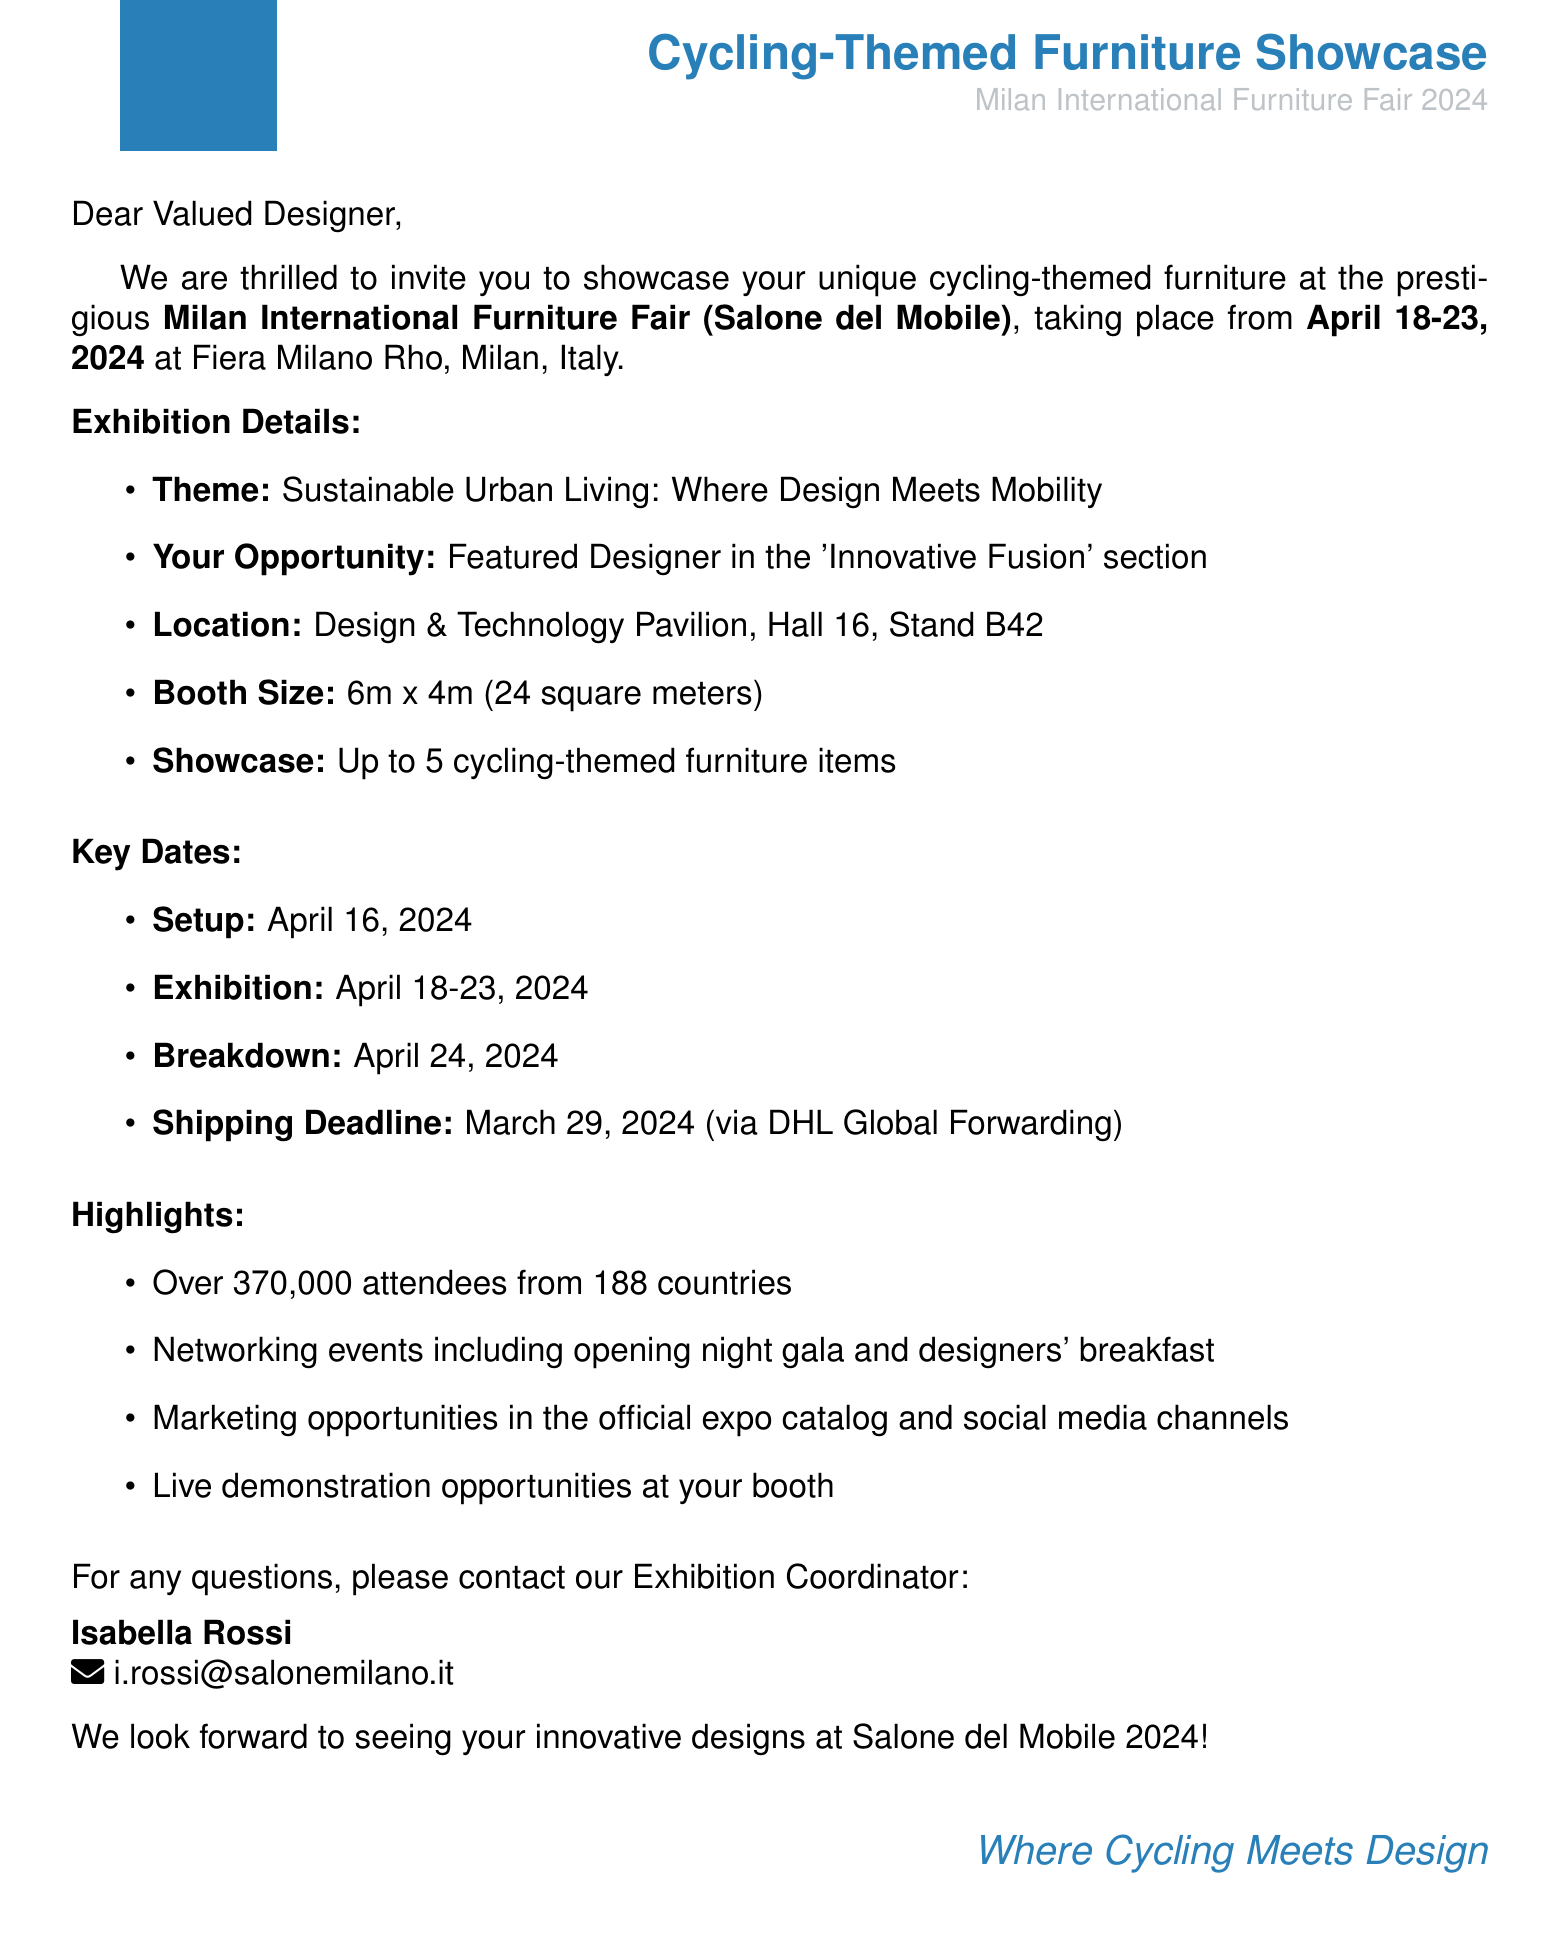What are the expo dates? The expo dates listed in the document are April 18-23, 2024.
Answer: April 18-23, 2024 What is the location of the expo? The document specifies that the location of the expo is Fiera Milano Rho, Milan, Italy.
Answer: Fiera Milano Rho, Milan, Italy What is the booth size? The booth size mentioned in the document is 6m x 4m (24 square meters).
Answer: 6m x 4m (24 square meters) How many furniture pieces can be showcased? The document states that up to 5 cycling-themed furniture items can be showcased.
Answer: 5 cycling-themed furniture items When is the setup date? The setup date provided in the document is April 16, 2024.
Answer: April 16, 2024 Who is the exhibition coordinator? The document mentions Isabella Rossi as the exhibition coordinator.
Answer: Isabella Rossi How many expected attendees are there? The document states that there are over 370,000 expected attendees.
Answer: Over 370,000 attendees What is the theme of the exhibition? The theme of the exhibition listed in the document is Sustainable Urban Living: Where Design Meets Mobility.
Answer: Sustainable Urban Living: Where Design Meets Mobility What shipping partner is mentioned? The document specifies DHL Global Forwarding as the shipping partner.
Answer: DHL Global Forwarding 